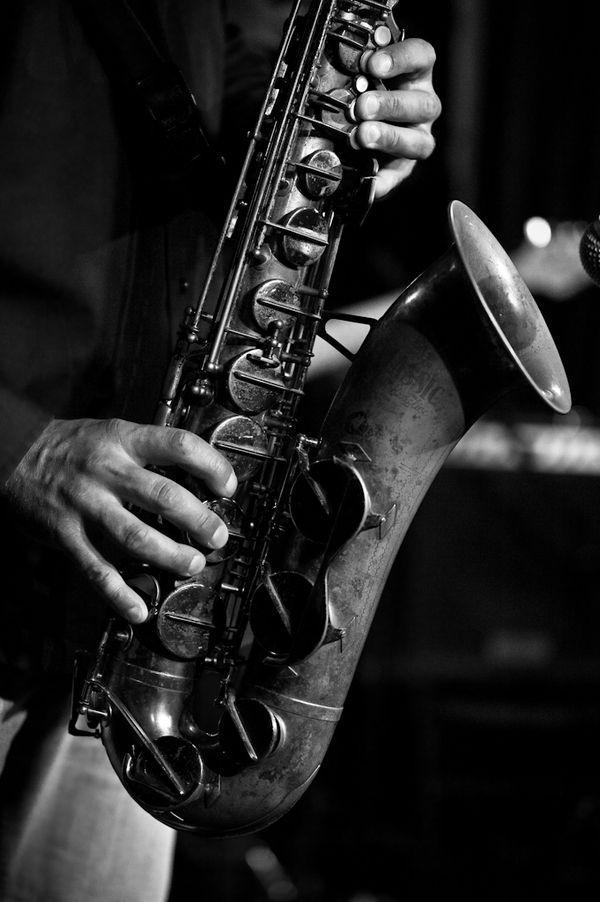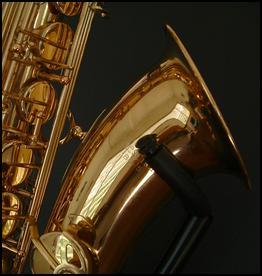The first image is the image on the left, the second image is the image on the right. For the images shown, is this caption "At least one sax has water coming out of it." true? Answer yes or no. No. The first image is the image on the left, the second image is the image on the right. Given the left and right images, does the statement "In one or more if the images a musical instrument has been converted to function as a water fountain." hold true? Answer yes or no. No. 